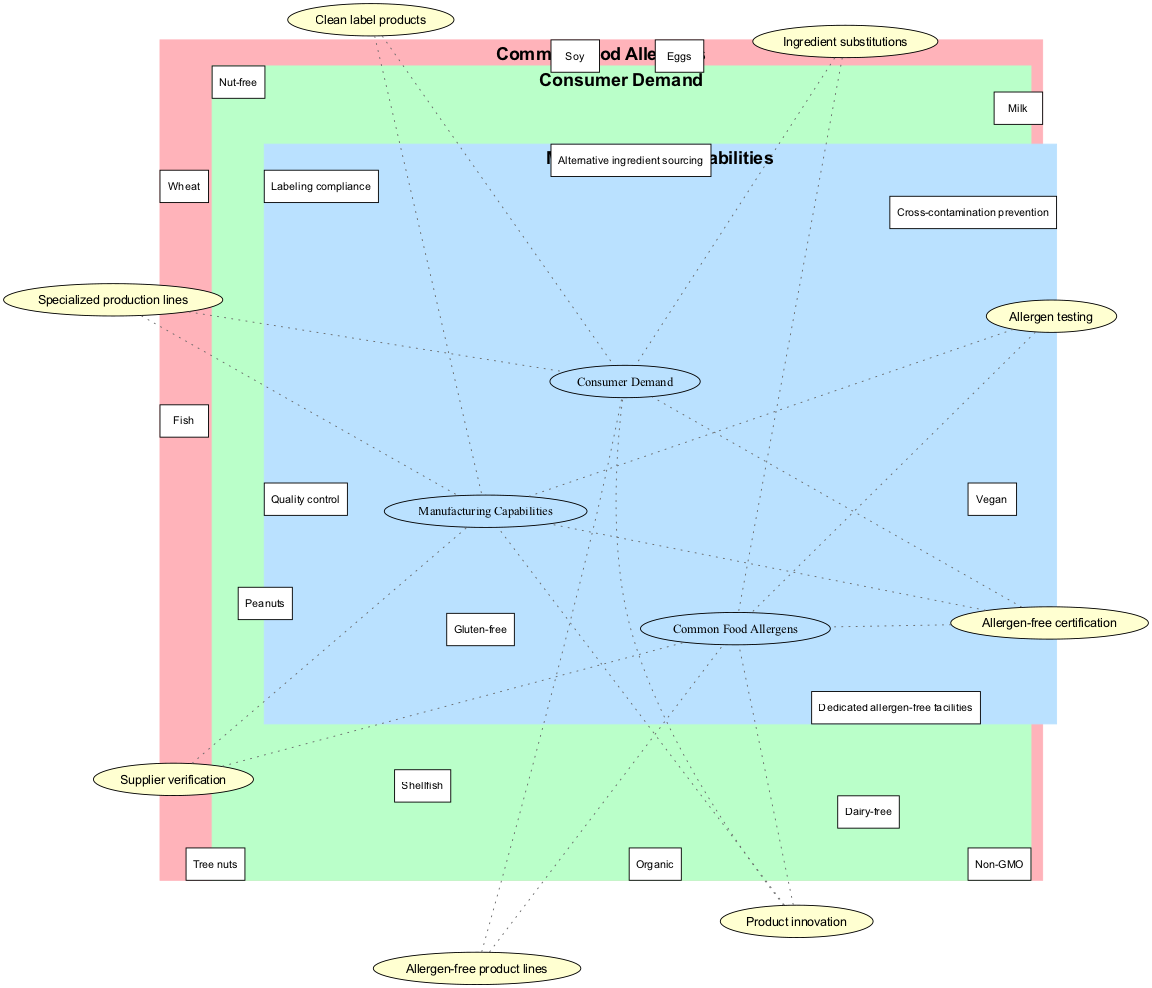What are the elements in the "Common Food Allergens" set? The "Common Food Allergens" set contains elements that represent typical allergens found in food products. These allergens are listed directly in the diagram.
Answer: Peanuts, Tree nuts, Milk, Eggs, Soy, Wheat, Fish, Shellfish What are the elements in the "Consumer Demand" set? The "Consumer Demand" set includes various consumer preferences related to food, which are clearly indicated in the diagram under this category.
Answer: Gluten-free, Dairy-free, Nut-free, Organic, Non-GMO, Vegan How many elements are shared between "Common Food Allergens" and "Consumer Demand"? The intersection of "Common Food Allergens" and "Consumer Demand" shows elements that are related to both categories, specifically represented in the overlapping area of the diagram. There are two elements listed in this intersection.
Answer: 2 What are the elements that fall under the intersection of all three sets? The intersection of all three sets, "Common Food Allergens," "Consumer Demand," and "Manufacturing Capabilities," includes elements that address the needs and demands corresponding to allergens and consumer preferences, as depicted in that part of the diagram.
Answer: Allergen-free certification, Product innovation What manufacturing capability is associated with "Consumer Demand"? The intersection of "Consumer Demand" and "Manufacturing Capabilities" represents the specific capabilities that cater to the demands of consumers. The diagram points out the relevant manufacturing capabilities directly.
Answer: Clean label products, Specialized production lines What are the elements that relate "Common Food Allergens" to "Manufacturing Capabilities"? To see the connection between "Common Food Allergens" and "Manufacturing Capabilities," we refer to the intersection area indicated in the diagram. These elements highlight the necessary actions taken to ensure safety and compliance regarding allergens.
Answer: Allergen testing, Supplier verification Which set has more elements, "Common Food Allergens" or "Manufacturing Capabilities"? The number of elements in each set can be compared by counting the elements listed under "Common Food Allergens" and "Manufacturing Capabilities" in the diagram. The "Common Food Allergens" has more elements.
Answer: Common Food Allergens What is the relationship between "Dedicated allergen-free facilities" and "Gluten-free"? The diagram shows that "Dedicated allergen-free facilities" falls under the "Manufacturing Capabilities" set and does not directly connect to "Gluten-free," which is a consumer demand. Therefore, there's no direct intersection shown.
Answer: No direct relationship How many total sets are represented in this diagram? The diagram visually represents three distinct sets, which can be counted from the titles presented at the beginning of each section in the diagram.
Answer: 3 What type of product innovation is suggested by the overlap of all three sets? The overlap indicates elements that address innovative solutions in the food industry, combining aspects of allergens, consumer demand, and manufacturing capabilities as shown in the joined intersection of the three sets.
Answer: Allergen-free certification, Product innovation 